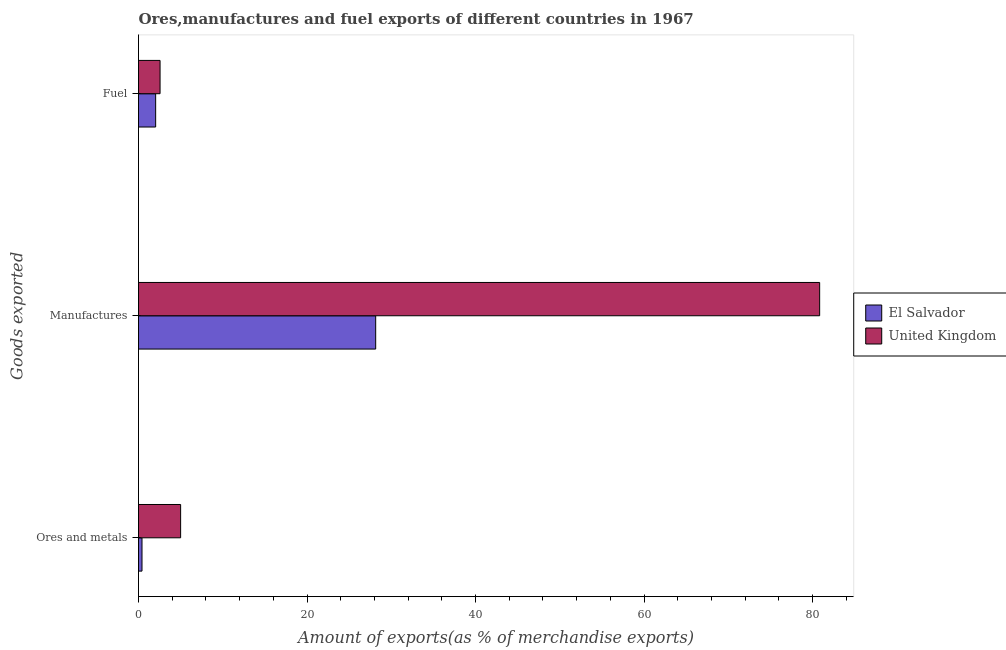How many groups of bars are there?
Offer a very short reply. 3. Are the number of bars on each tick of the Y-axis equal?
Ensure brevity in your answer.  Yes. How many bars are there on the 3rd tick from the bottom?
Your answer should be compact. 2. What is the label of the 3rd group of bars from the top?
Keep it short and to the point. Ores and metals. What is the percentage of ores and metals exports in United Kingdom?
Your answer should be very brief. 5. Across all countries, what is the maximum percentage of manufactures exports?
Provide a succinct answer. 80.84. Across all countries, what is the minimum percentage of ores and metals exports?
Your answer should be compact. 0.42. In which country was the percentage of ores and metals exports minimum?
Give a very brief answer. El Salvador. What is the total percentage of fuel exports in the graph?
Give a very brief answer. 4.59. What is the difference between the percentage of fuel exports in El Salvador and that in United Kingdom?
Offer a terse response. -0.52. What is the difference between the percentage of ores and metals exports in United Kingdom and the percentage of fuel exports in El Salvador?
Keep it short and to the point. 2.96. What is the average percentage of ores and metals exports per country?
Provide a short and direct response. 2.71. What is the difference between the percentage of ores and metals exports and percentage of manufactures exports in United Kingdom?
Your answer should be very brief. -75.84. In how many countries, is the percentage of manufactures exports greater than 48 %?
Ensure brevity in your answer.  1. What is the ratio of the percentage of manufactures exports in El Salvador to that in United Kingdom?
Your response must be concise. 0.35. Is the percentage of fuel exports in United Kingdom less than that in El Salvador?
Ensure brevity in your answer.  No. What is the difference between the highest and the second highest percentage of manufactures exports?
Offer a terse response. 52.69. What is the difference between the highest and the lowest percentage of ores and metals exports?
Your response must be concise. 4.58. Is the sum of the percentage of fuel exports in El Salvador and United Kingdom greater than the maximum percentage of manufactures exports across all countries?
Give a very brief answer. No. What does the 2nd bar from the bottom in Fuel represents?
Keep it short and to the point. United Kingdom. Is it the case that in every country, the sum of the percentage of ores and metals exports and percentage of manufactures exports is greater than the percentage of fuel exports?
Ensure brevity in your answer.  Yes. How many bars are there?
Offer a terse response. 6. Are all the bars in the graph horizontal?
Your response must be concise. Yes. What is the difference between two consecutive major ticks on the X-axis?
Keep it short and to the point. 20. Does the graph contain any zero values?
Provide a succinct answer. No. Does the graph contain grids?
Ensure brevity in your answer.  No. Where does the legend appear in the graph?
Keep it short and to the point. Center right. How many legend labels are there?
Make the answer very short. 2. What is the title of the graph?
Offer a very short reply. Ores,manufactures and fuel exports of different countries in 1967. Does "Botswana" appear as one of the legend labels in the graph?
Offer a very short reply. No. What is the label or title of the X-axis?
Offer a terse response. Amount of exports(as % of merchandise exports). What is the label or title of the Y-axis?
Give a very brief answer. Goods exported. What is the Amount of exports(as % of merchandise exports) of El Salvador in Ores and metals?
Give a very brief answer. 0.42. What is the Amount of exports(as % of merchandise exports) in United Kingdom in Ores and metals?
Offer a terse response. 5. What is the Amount of exports(as % of merchandise exports) of El Salvador in Manufactures?
Keep it short and to the point. 28.15. What is the Amount of exports(as % of merchandise exports) of United Kingdom in Manufactures?
Make the answer very short. 80.84. What is the Amount of exports(as % of merchandise exports) of El Salvador in Fuel?
Make the answer very short. 2.03. What is the Amount of exports(as % of merchandise exports) of United Kingdom in Fuel?
Ensure brevity in your answer.  2.56. Across all Goods exported, what is the maximum Amount of exports(as % of merchandise exports) in El Salvador?
Your response must be concise. 28.15. Across all Goods exported, what is the maximum Amount of exports(as % of merchandise exports) of United Kingdom?
Provide a short and direct response. 80.84. Across all Goods exported, what is the minimum Amount of exports(as % of merchandise exports) in El Salvador?
Your response must be concise. 0.42. Across all Goods exported, what is the minimum Amount of exports(as % of merchandise exports) in United Kingdom?
Ensure brevity in your answer.  2.56. What is the total Amount of exports(as % of merchandise exports) of El Salvador in the graph?
Your answer should be compact. 30.6. What is the total Amount of exports(as % of merchandise exports) in United Kingdom in the graph?
Provide a short and direct response. 88.4. What is the difference between the Amount of exports(as % of merchandise exports) in El Salvador in Ores and metals and that in Manufactures?
Provide a short and direct response. -27.74. What is the difference between the Amount of exports(as % of merchandise exports) of United Kingdom in Ores and metals and that in Manufactures?
Keep it short and to the point. -75.84. What is the difference between the Amount of exports(as % of merchandise exports) in El Salvador in Ores and metals and that in Fuel?
Provide a succinct answer. -1.62. What is the difference between the Amount of exports(as % of merchandise exports) of United Kingdom in Ores and metals and that in Fuel?
Offer a very short reply. 2.44. What is the difference between the Amount of exports(as % of merchandise exports) in El Salvador in Manufactures and that in Fuel?
Offer a terse response. 26.12. What is the difference between the Amount of exports(as % of merchandise exports) of United Kingdom in Manufactures and that in Fuel?
Provide a succinct answer. 78.29. What is the difference between the Amount of exports(as % of merchandise exports) of El Salvador in Ores and metals and the Amount of exports(as % of merchandise exports) of United Kingdom in Manufactures?
Your answer should be compact. -80.43. What is the difference between the Amount of exports(as % of merchandise exports) in El Salvador in Ores and metals and the Amount of exports(as % of merchandise exports) in United Kingdom in Fuel?
Make the answer very short. -2.14. What is the difference between the Amount of exports(as % of merchandise exports) in El Salvador in Manufactures and the Amount of exports(as % of merchandise exports) in United Kingdom in Fuel?
Your answer should be very brief. 25.59. What is the average Amount of exports(as % of merchandise exports) of El Salvador per Goods exported?
Keep it short and to the point. 10.2. What is the average Amount of exports(as % of merchandise exports) in United Kingdom per Goods exported?
Offer a terse response. 29.47. What is the difference between the Amount of exports(as % of merchandise exports) of El Salvador and Amount of exports(as % of merchandise exports) of United Kingdom in Ores and metals?
Your response must be concise. -4.58. What is the difference between the Amount of exports(as % of merchandise exports) in El Salvador and Amount of exports(as % of merchandise exports) in United Kingdom in Manufactures?
Ensure brevity in your answer.  -52.69. What is the difference between the Amount of exports(as % of merchandise exports) in El Salvador and Amount of exports(as % of merchandise exports) in United Kingdom in Fuel?
Ensure brevity in your answer.  -0.52. What is the ratio of the Amount of exports(as % of merchandise exports) of El Salvador in Ores and metals to that in Manufactures?
Make the answer very short. 0.01. What is the ratio of the Amount of exports(as % of merchandise exports) of United Kingdom in Ores and metals to that in Manufactures?
Keep it short and to the point. 0.06. What is the ratio of the Amount of exports(as % of merchandise exports) of El Salvador in Ores and metals to that in Fuel?
Provide a short and direct response. 0.2. What is the ratio of the Amount of exports(as % of merchandise exports) of United Kingdom in Ores and metals to that in Fuel?
Keep it short and to the point. 1.95. What is the ratio of the Amount of exports(as % of merchandise exports) in El Salvador in Manufactures to that in Fuel?
Provide a short and direct response. 13.83. What is the ratio of the Amount of exports(as % of merchandise exports) in United Kingdom in Manufactures to that in Fuel?
Your answer should be very brief. 31.6. What is the difference between the highest and the second highest Amount of exports(as % of merchandise exports) of El Salvador?
Offer a terse response. 26.12. What is the difference between the highest and the second highest Amount of exports(as % of merchandise exports) of United Kingdom?
Ensure brevity in your answer.  75.84. What is the difference between the highest and the lowest Amount of exports(as % of merchandise exports) in El Salvador?
Keep it short and to the point. 27.74. What is the difference between the highest and the lowest Amount of exports(as % of merchandise exports) of United Kingdom?
Keep it short and to the point. 78.29. 